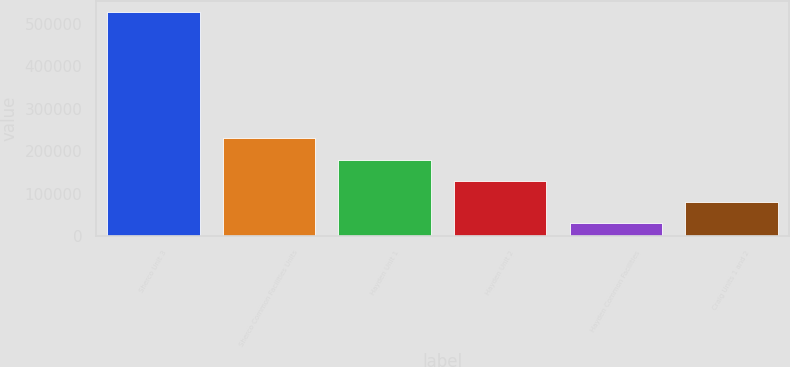<chart> <loc_0><loc_0><loc_500><loc_500><bar_chart><fcel>Sherco Unit 3<fcel>Sherco Common Facilities Units<fcel>Hayden Unit 1<fcel>Hayden Unit 2<fcel>Hayden Common Facilities<fcel>Craig Units 1 and 2<nl><fcel>527647<fcel>229997<fcel>180388<fcel>130780<fcel>31563<fcel>81171.4<nl></chart> 